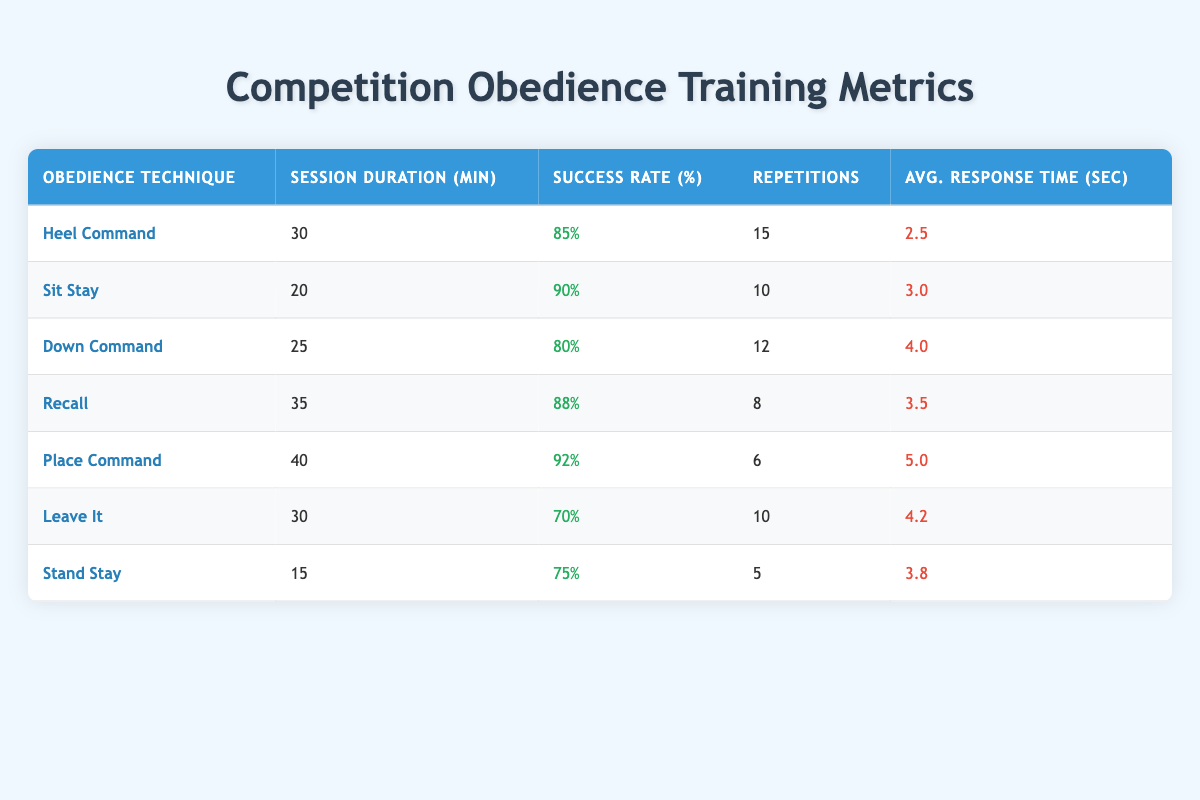What is the success rate for the "Sit Stay" technique? The "Sit Stay" technique has a success rate percentage of 90%, which can be directly found in the table under the corresponding row for this technique.
Answer: 90% Which technique has the highest average response time? The "Place Command" technique has an average response time of 5 seconds, which is the highest among all the listed techniques according to the table.
Answer: 5 How many repetitions were done for the "Leave It" technique? Referring to the table, the "Leave It" technique had a total of 10 repetitions during the training session.
Answer: 10 What is the total session duration for the "Down Command" and "Stand Stay" techniques combined? The session duration for "Down Command" is 25 minutes and for "Stand Stay" is 15 minutes. Adding these gives: 25 + 15 = 40 minutes total for both techniques.
Answer: 40 Is the success rate for "Heel Command" less than 80%? The success rate for "Heel Command" is 85%, which is greater than 80%, making the statement false.
Answer: No What is the average number of repetitions across all techniques? To find the average: add up all repetitions (15 + 10 + 12 + 8 + 6 + 10 + 5 = 66), then divide by the number of techniques (7): 66 / 7 = 9.43 repetitions on average.
Answer: 9.43 Which obedience technique required the least amount of session duration? The "Stand Stay" technique had the least session duration at 15 minutes, as confirmed by checking the durations listed in the table.
Answer: 15 How does the success rate of "Down Command" compare to that of "Recall"? The "Down Command" has a success rate of 80% and "Recall" has 88%. Comparing them, 80% is less than 88%, confirming that "Recall" has a higher success rate.
Answer: Recall has a higher success rate What is the difference in average response time between "Leave It" and "Place Command"? The "Leave It" technique has an average response time of 4.2 seconds, and "Place Command" has 5 seconds. Calculating the difference gives: 5 - 4.2 = 0.8 seconds.
Answer: 0.8 seconds 